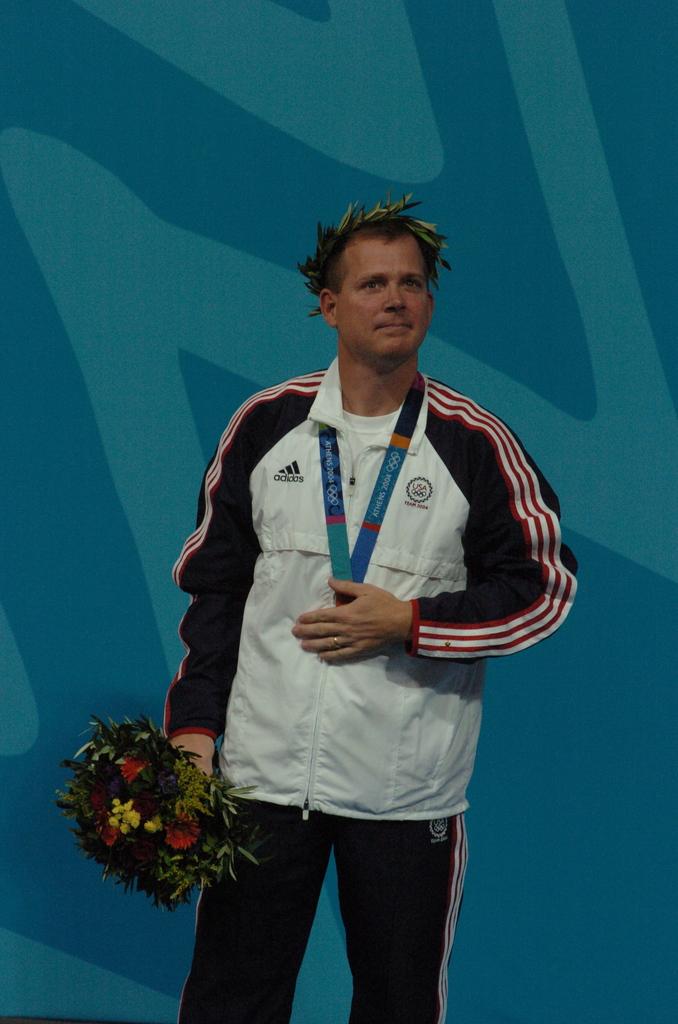What brand is on the top left of the garment?
Offer a terse response. Adidas. Does adidas sponsor this jersey?
Keep it short and to the point. Yes. 